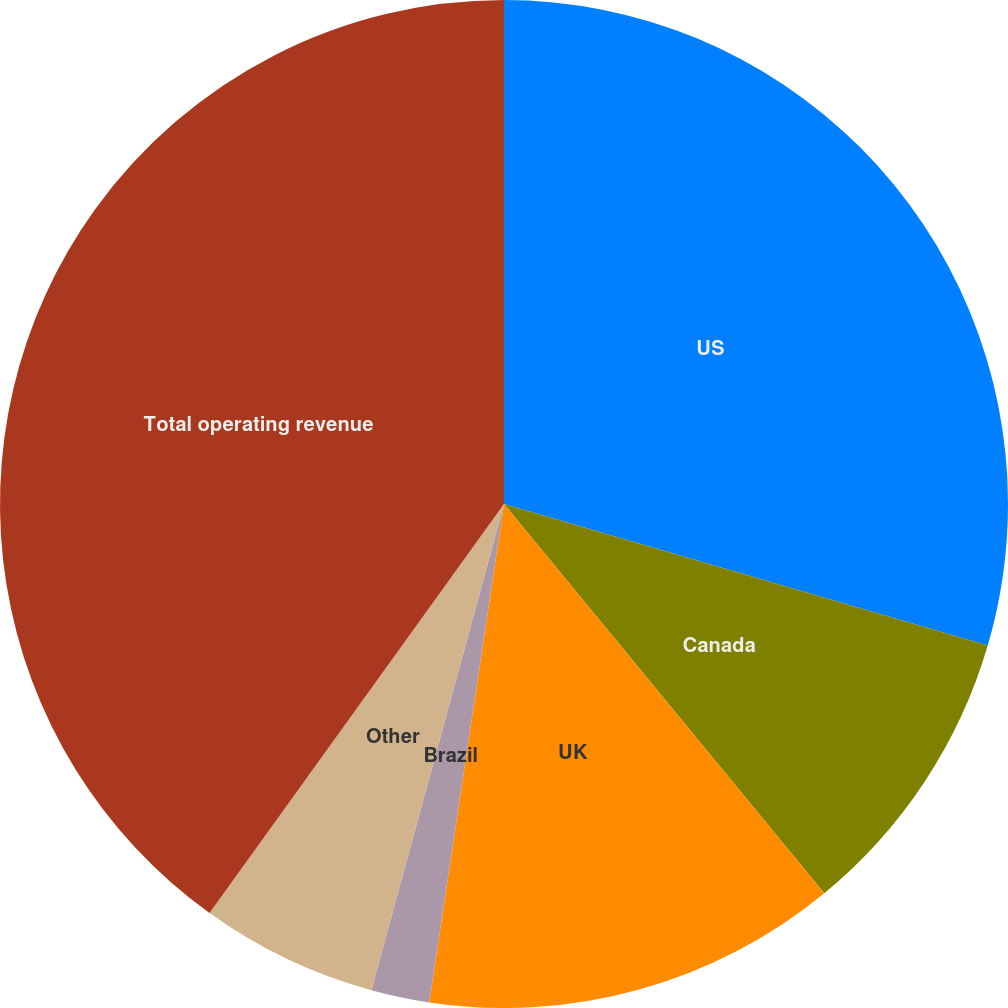Convert chart. <chart><loc_0><loc_0><loc_500><loc_500><pie_chart><fcel>US<fcel>Canada<fcel>UK<fcel>Brazil<fcel>Other<fcel>Total operating revenue<nl><fcel>29.53%<fcel>9.51%<fcel>13.33%<fcel>1.87%<fcel>5.69%<fcel>40.07%<nl></chart> 